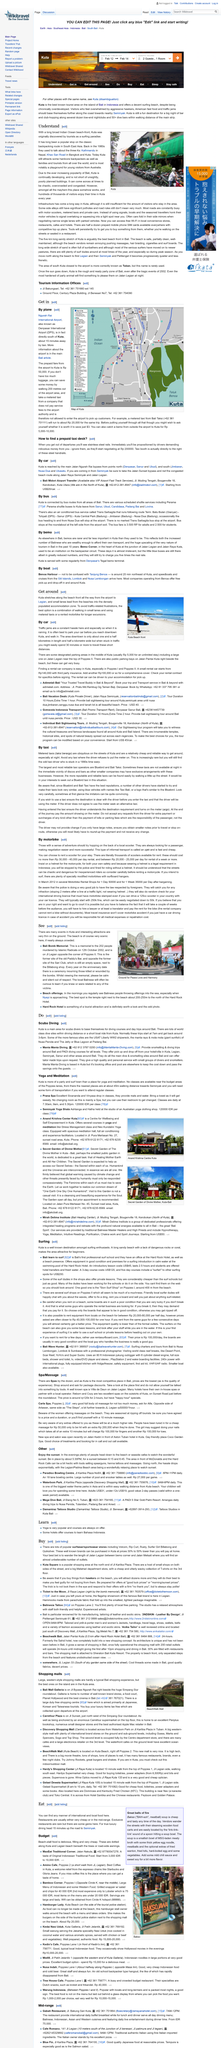Indicate a few pertinent items in this graphic. Kuta is widely recognized for being a popular destination among surfing aficionados. Yes, car and boat are both transportation options available in or near Kuta. The above picture portrays a vision of peace, love, and harmony, symbolized by the intertwined hands of different races and genders, representing the unity and coexistence of all human beings. The estimated rental cost for a scooter for a day ranges from Rp 30,000 to Rp 40,000. Spas in Kuta generally cost around Rp120,000 for a two-hour session. 